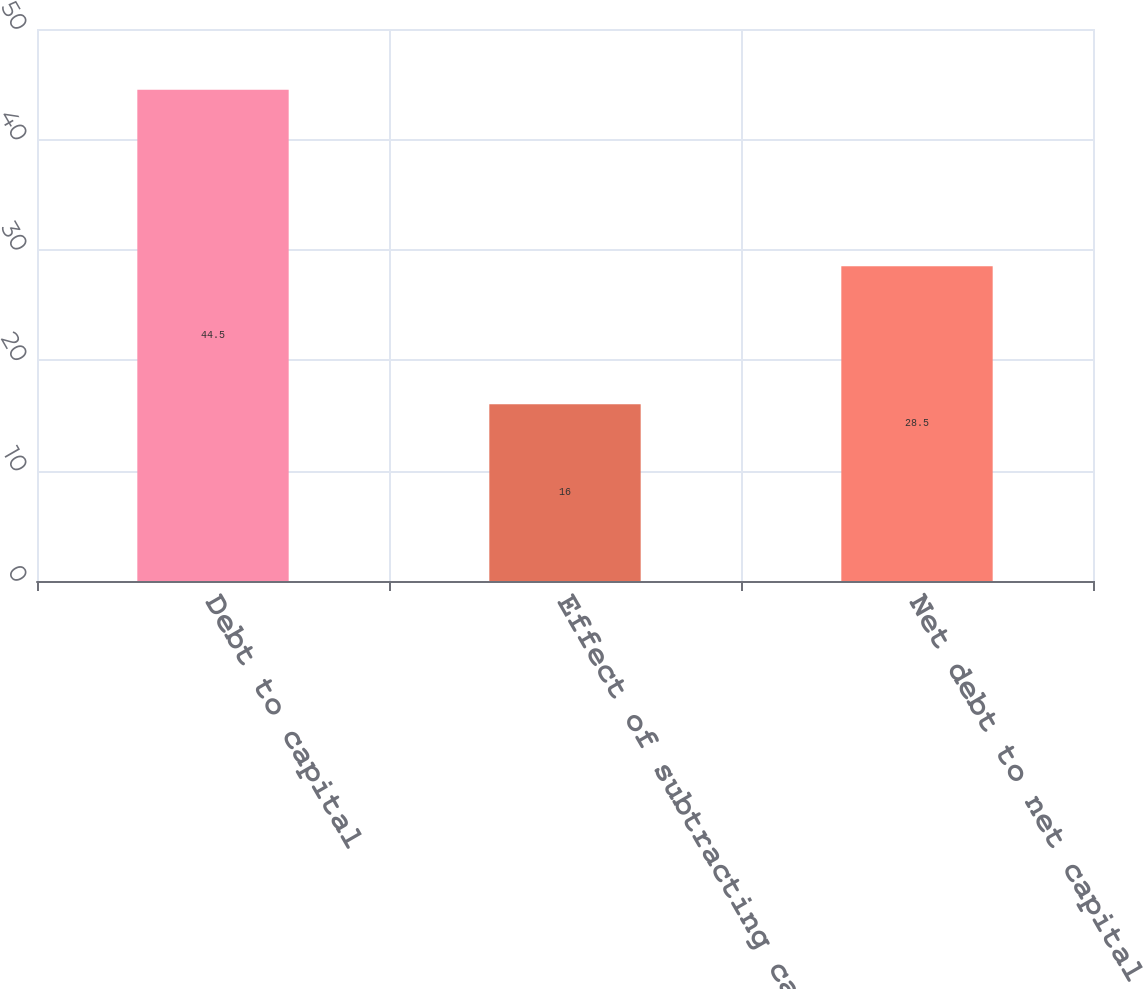<chart> <loc_0><loc_0><loc_500><loc_500><bar_chart><fcel>Debt to capital<fcel>Effect of subtracting cash<fcel>Net debt to net capital<nl><fcel>44.5<fcel>16<fcel>28.5<nl></chart> 